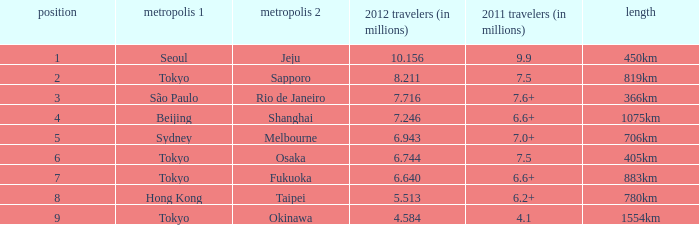How many passengers (in millions) in 2011 flew through along the route that had 6.640 million passengers in 2012? 6.6+. 